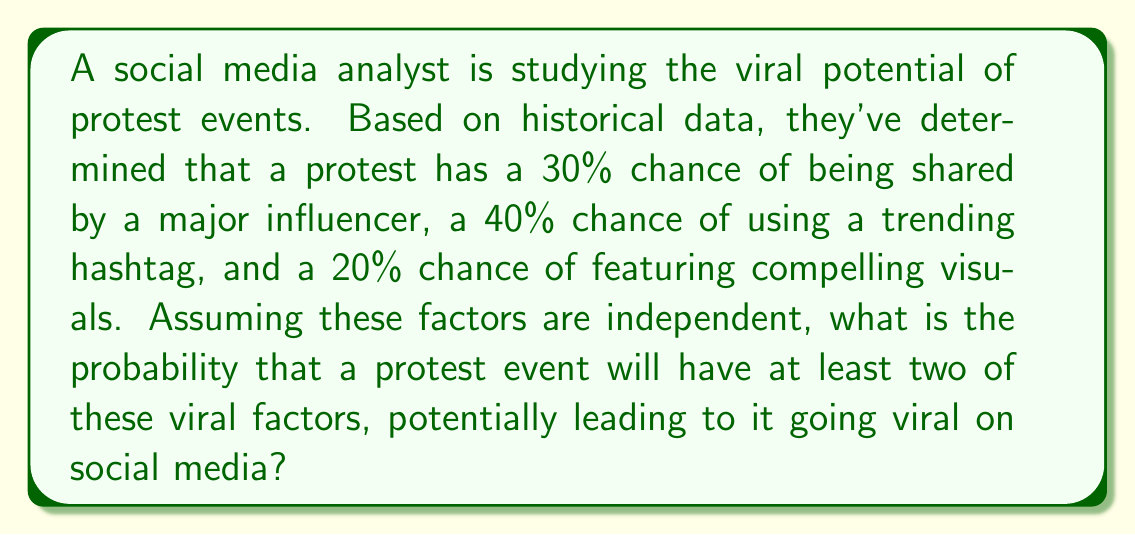Give your solution to this math problem. Let's approach this step-by-step:

1) First, let's define our events:
   A: Shared by a major influencer (P(A) = 0.30)
   B: Uses a trending hashtag (P(B) = 0.40)
   C: Features compelling visuals (P(C) = 0.20)

2) We need to find the probability of at least two of these events occurring. It's easier to calculate the complement of this - the probability of 0 or 1 event occurring - and then subtract from 1.

3) Probability of 0 events occurring:
   P(none) = (1-0.30)(1-0.40)(1-0.20) = 0.70 * 0.60 * 0.80 = 0.336

4) Probability of exactly 1 event occurring:
   P(A only) = 0.30 * 0.60 * 0.80 = 0.144
   P(B only) = 0.70 * 0.40 * 0.80 = 0.224
   P(C only) = 0.70 * 0.60 * 0.20 = 0.084
   P(exactly 1) = 0.144 + 0.224 + 0.084 = 0.452

5) Probability of 0 or 1 event:
   P(0 or 1) = 0.336 + 0.452 = 0.788

6) Therefore, the probability of at least 2 events:
   P(at least 2) = 1 - P(0 or 1) = 1 - 0.788 = 0.212

Thus, there is a 21.2% chance that a protest event will have at least two viral factors.
Answer: 0.212 or 21.2% 